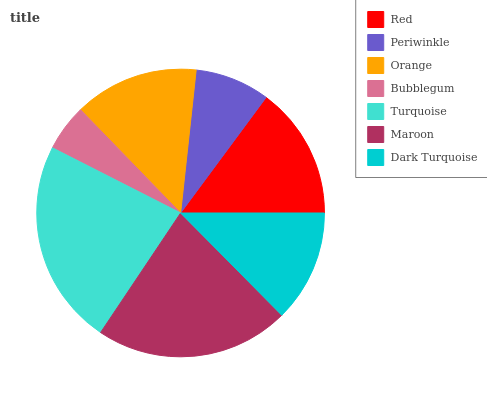Is Bubblegum the minimum?
Answer yes or no. Yes. Is Turquoise the maximum?
Answer yes or no. Yes. Is Periwinkle the minimum?
Answer yes or no. No. Is Periwinkle the maximum?
Answer yes or no. No. Is Red greater than Periwinkle?
Answer yes or no. Yes. Is Periwinkle less than Red?
Answer yes or no. Yes. Is Periwinkle greater than Red?
Answer yes or no. No. Is Red less than Periwinkle?
Answer yes or no. No. Is Orange the high median?
Answer yes or no. Yes. Is Orange the low median?
Answer yes or no. Yes. Is Bubblegum the high median?
Answer yes or no. No. Is Turquoise the low median?
Answer yes or no. No. 